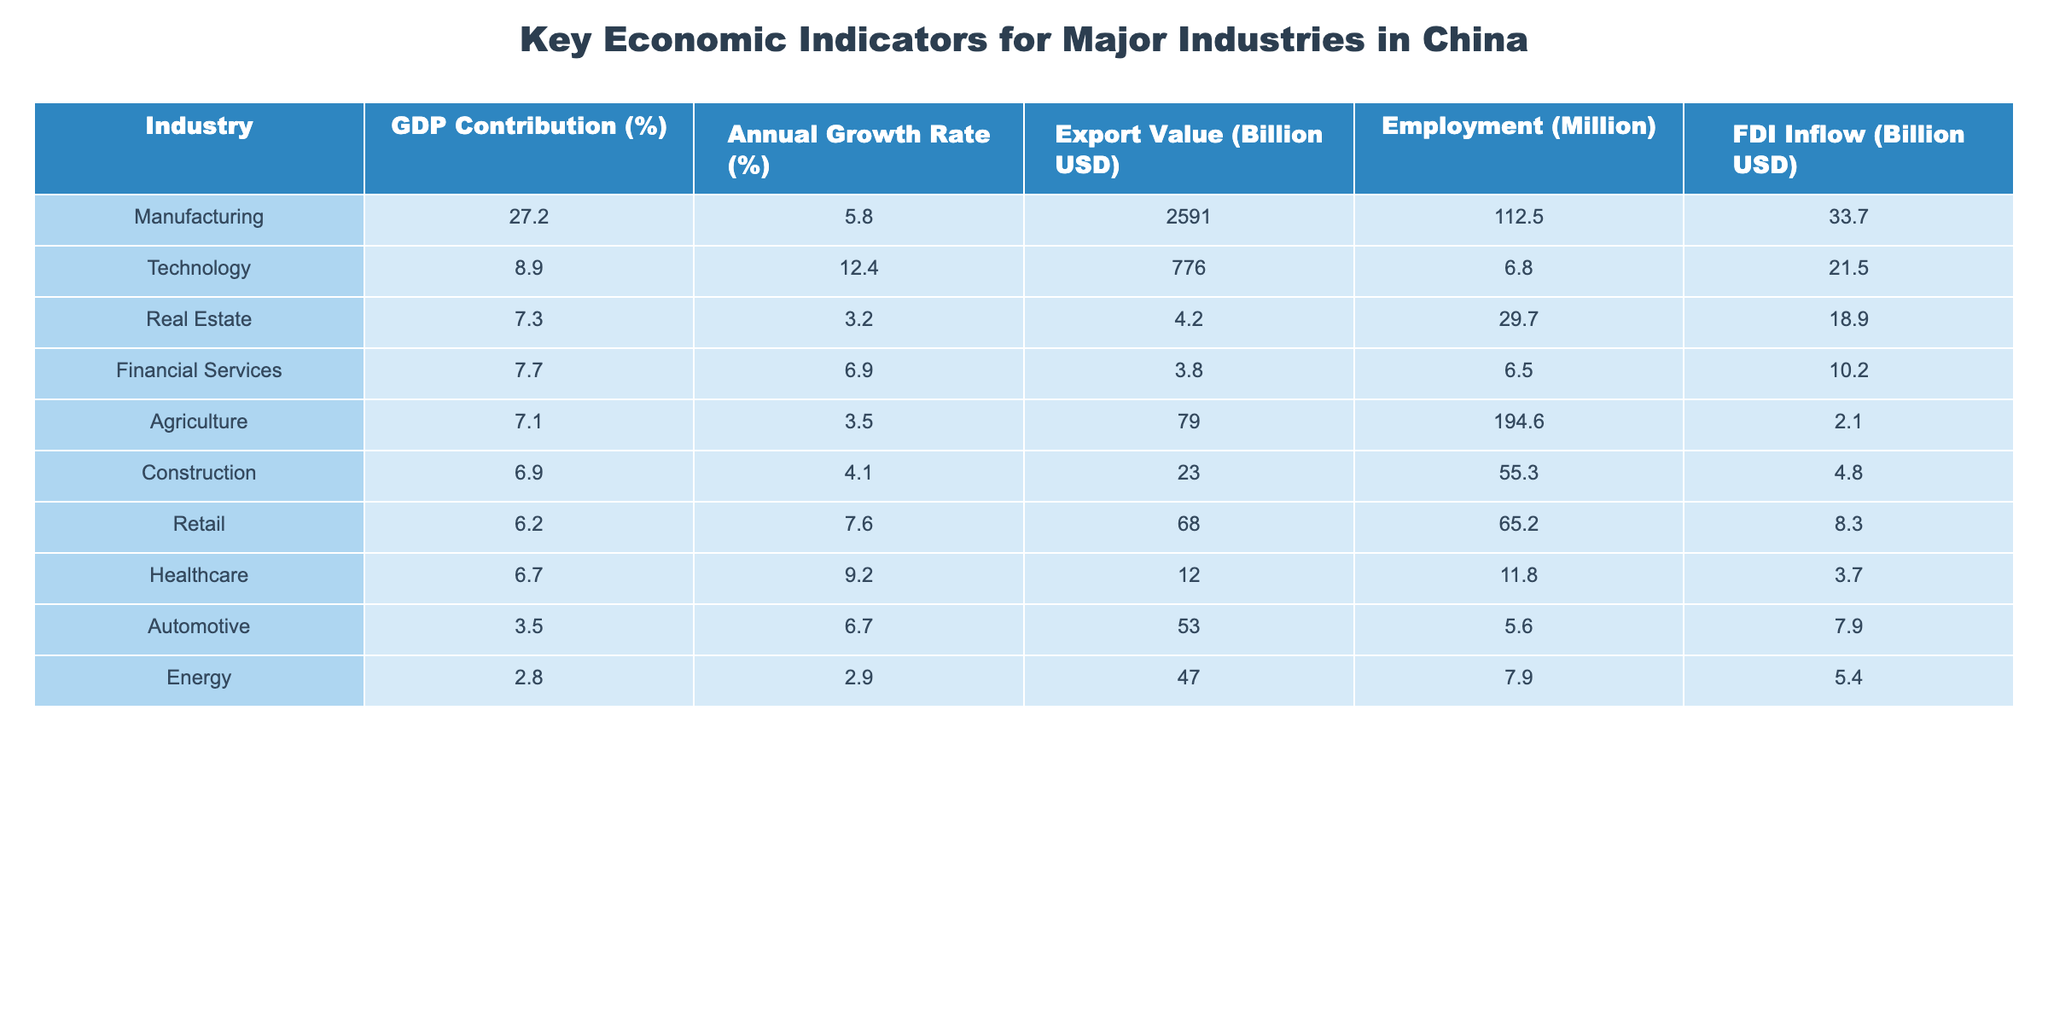What is the GDP contribution percentage of the Manufacturing industry? Referring to the table, the Manufacturing industry has a GDP contribution of 27.2%.
Answer: 27.2% Which industry has the highest annual growth rate? By comparing the annual growth rates listed, the Technology industry at 12.4% has the highest annual growth rate.
Answer: Technology What is the export value of the Agriculture industry? The table indicates that the export value of the Agriculture industry is 79 billion USD.
Answer: 79 billion USD How many million people are employed in the Real Estate industry? The table shows that 29.7 million people are employed in the Real Estate industry.
Answer: 29.7 million What is the total employment across the Manufacturing and Technology industries? The total employment is the sum of the Manufacturing (112.5 million) and Technology (6.8 million) employments: 112.5 + 6.8 = 119.3 million.
Answer: 119.3 million Is the export value of the Healthcare industry greater than that of the Automotive industry? By checking the export values, the Healthcare industry has an export value of 12 billion USD, while the Automotive industry has 53 billion USD, making the statement false.
Answer: No What is the difference in FDI inflow between the Financial Services and Construction industries? The FDI inflow for Financial Services is 10.2 billion USD and for Construction is 4.8 billion USD. The difference is 10.2 - 4.8 = 5.4 billion USD.
Answer: 5.4 billion USD Which industry contributes less than 5% to the GDP? By reviewing the data, the Energy industry contributes 2.8% to the GDP, which is less than 5%.
Answer: Energy What is the average GDP contribution percentage of the Retail and Healthcare industries? The GDP contributions for Retail and Healthcare are 6.2% and 6.7% respectively. To find the average, sum them: 6.2 + 6.7 = 12.9 and then divide by 2, which gives 12.9/2 = 6.45%.
Answer: 6.45% Which two industries have the lowest export values, and what are those values? The two industries with the lowest export values are Real Estate at 4.2 billion USD and Energy at 47 billion USD.
Answer: Real Estate (4.2 billion USD), Energy (47 billion USD) 